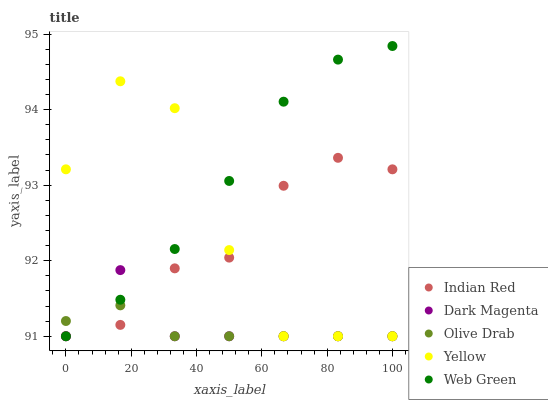Does Olive Drab have the minimum area under the curve?
Answer yes or no. Yes. Does Web Green have the maximum area under the curve?
Answer yes or no. Yes. Does Yellow have the minimum area under the curve?
Answer yes or no. No. Does Yellow have the maximum area under the curve?
Answer yes or no. No. Is Olive Drab the smoothest?
Answer yes or no. Yes. Is Yellow the roughest?
Answer yes or no. Yes. Is Web Green the smoothest?
Answer yes or no. No. Is Web Green the roughest?
Answer yes or no. No. Does Olive Drab have the lowest value?
Answer yes or no. Yes. Does Web Green have the highest value?
Answer yes or no. Yes. Does Yellow have the highest value?
Answer yes or no. No. Does Web Green intersect Yellow?
Answer yes or no. Yes. Is Web Green less than Yellow?
Answer yes or no. No. Is Web Green greater than Yellow?
Answer yes or no. No. 